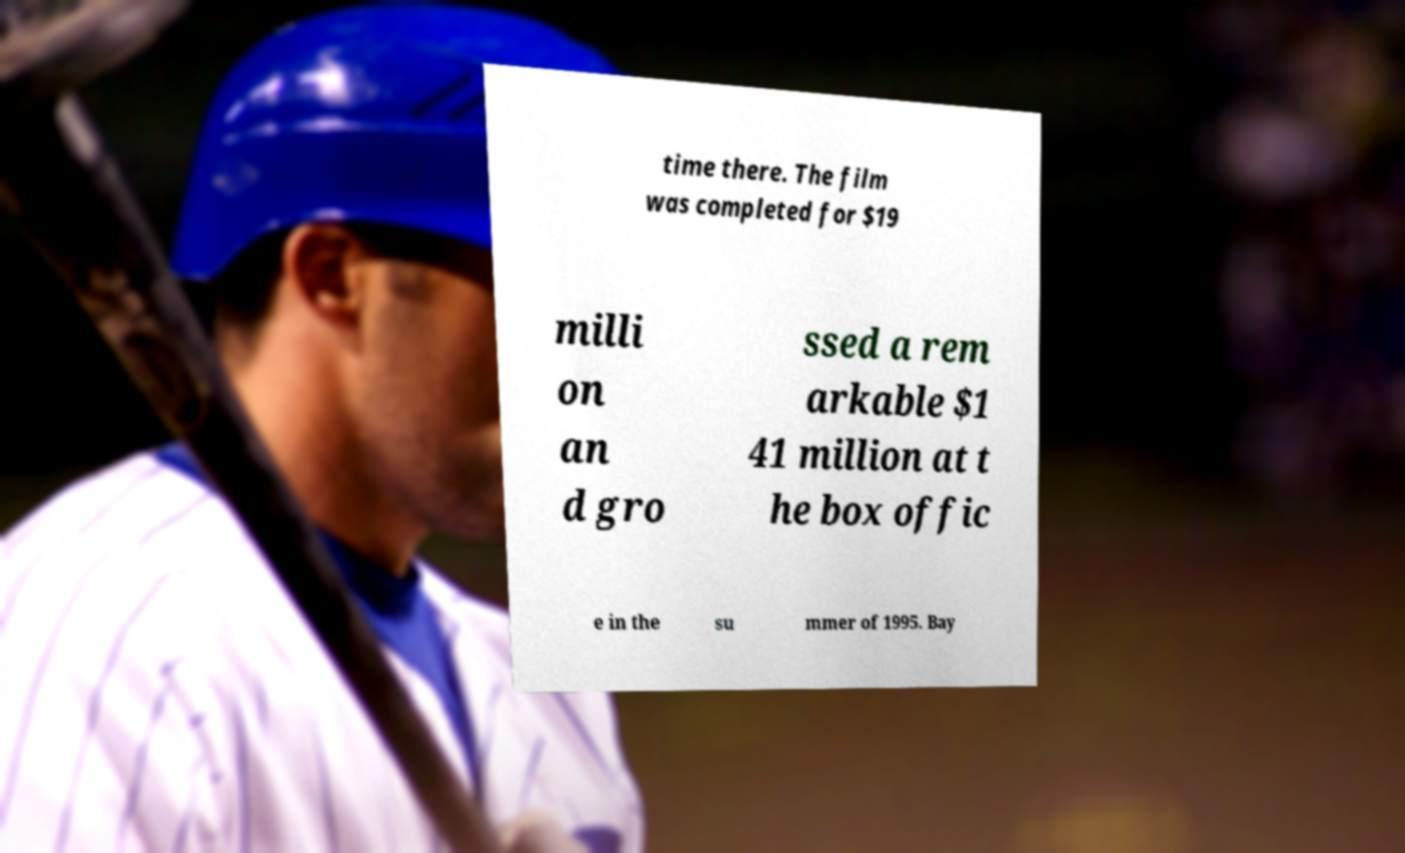Can you accurately transcribe the text from the provided image for me? time there. The film was completed for $19 milli on an d gro ssed a rem arkable $1 41 million at t he box offic e in the su mmer of 1995. Bay 